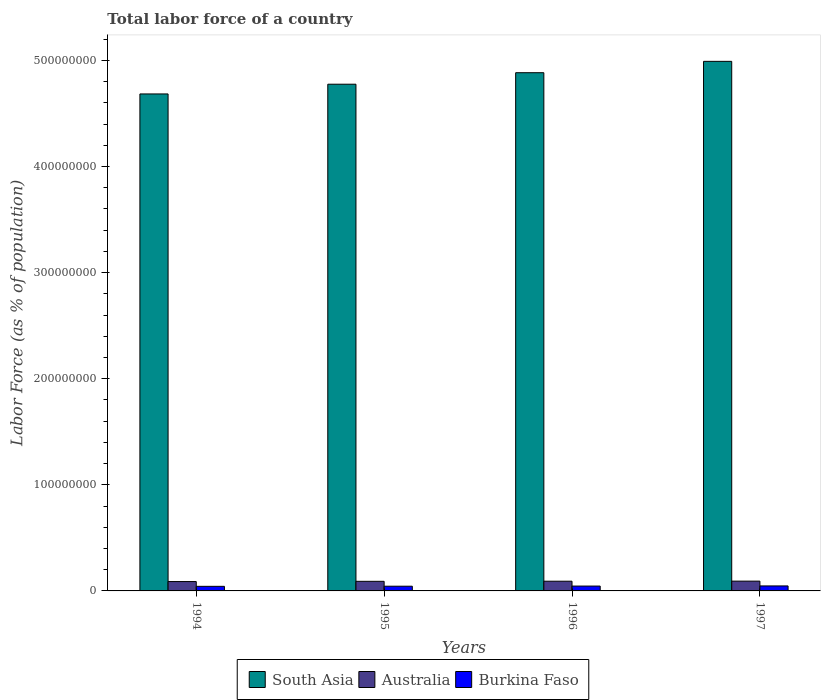How many groups of bars are there?
Give a very brief answer. 4. How many bars are there on the 1st tick from the right?
Offer a terse response. 3. In how many cases, is the number of bars for a given year not equal to the number of legend labels?
Provide a succinct answer. 0. What is the percentage of labor force in Australia in 1997?
Your answer should be very brief. 9.22e+06. Across all years, what is the maximum percentage of labor force in South Asia?
Offer a very short reply. 4.99e+08. Across all years, what is the minimum percentage of labor force in Australia?
Give a very brief answer. 8.83e+06. In which year was the percentage of labor force in Burkina Faso maximum?
Provide a succinct answer. 1997. What is the total percentage of labor force in Australia in the graph?
Make the answer very short. 3.63e+07. What is the difference between the percentage of labor force in Burkina Faso in 1995 and that in 1996?
Ensure brevity in your answer.  -1.23e+05. What is the difference between the percentage of labor force in Australia in 1997 and the percentage of labor force in South Asia in 1994?
Make the answer very short. -4.59e+08. What is the average percentage of labor force in South Asia per year?
Your answer should be compact. 4.83e+08. In the year 1996, what is the difference between the percentage of labor force in Burkina Faso and percentage of labor force in South Asia?
Offer a terse response. -4.84e+08. In how many years, is the percentage of labor force in Australia greater than 220000000 %?
Your answer should be very brief. 0. What is the ratio of the percentage of labor force in South Asia in 1994 to that in 1997?
Offer a terse response. 0.94. What is the difference between the highest and the second highest percentage of labor force in Burkina Faso?
Provide a succinct answer. 1.33e+05. What is the difference between the highest and the lowest percentage of labor force in Burkina Faso?
Offer a very short reply. 3.86e+05. What does the 3rd bar from the right in 1995 represents?
Keep it short and to the point. South Asia. How many bars are there?
Provide a succinct answer. 12. Are all the bars in the graph horizontal?
Give a very brief answer. No. How many years are there in the graph?
Provide a succinct answer. 4. What is the difference between two consecutive major ticks on the Y-axis?
Provide a succinct answer. 1.00e+08. Are the values on the major ticks of Y-axis written in scientific E-notation?
Provide a succinct answer. No. Does the graph contain grids?
Make the answer very short. No. What is the title of the graph?
Offer a terse response. Total labor force of a country. Does "St. Lucia" appear as one of the legend labels in the graph?
Your answer should be very brief. No. What is the label or title of the Y-axis?
Your answer should be compact. Labor Force (as % of population). What is the Labor Force (as % of population) of South Asia in 1994?
Provide a succinct answer. 4.68e+08. What is the Labor Force (as % of population) in Australia in 1994?
Keep it short and to the point. 8.83e+06. What is the Labor Force (as % of population) of Burkina Faso in 1994?
Offer a very short reply. 4.31e+06. What is the Labor Force (as % of population) of South Asia in 1995?
Ensure brevity in your answer.  4.78e+08. What is the Labor Force (as % of population) in Australia in 1995?
Your answer should be compact. 9.05e+06. What is the Labor Force (as % of population) of Burkina Faso in 1995?
Your answer should be compact. 4.45e+06. What is the Labor Force (as % of population) in South Asia in 1996?
Your answer should be very brief. 4.88e+08. What is the Labor Force (as % of population) in Australia in 1996?
Ensure brevity in your answer.  9.15e+06. What is the Labor Force (as % of population) of Burkina Faso in 1996?
Offer a terse response. 4.57e+06. What is the Labor Force (as % of population) in South Asia in 1997?
Keep it short and to the point. 4.99e+08. What is the Labor Force (as % of population) of Australia in 1997?
Provide a succinct answer. 9.22e+06. What is the Labor Force (as % of population) of Burkina Faso in 1997?
Your answer should be very brief. 4.70e+06. Across all years, what is the maximum Labor Force (as % of population) of South Asia?
Give a very brief answer. 4.99e+08. Across all years, what is the maximum Labor Force (as % of population) of Australia?
Ensure brevity in your answer.  9.22e+06. Across all years, what is the maximum Labor Force (as % of population) in Burkina Faso?
Keep it short and to the point. 4.70e+06. Across all years, what is the minimum Labor Force (as % of population) of South Asia?
Your answer should be compact. 4.68e+08. Across all years, what is the minimum Labor Force (as % of population) in Australia?
Provide a short and direct response. 8.83e+06. Across all years, what is the minimum Labor Force (as % of population) of Burkina Faso?
Your answer should be very brief. 4.31e+06. What is the total Labor Force (as % of population) of South Asia in the graph?
Give a very brief answer. 1.93e+09. What is the total Labor Force (as % of population) of Australia in the graph?
Offer a very short reply. 3.63e+07. What is the total Labor Force (as % of population) in Burkina Faso in the graph?
Your answer should be very brief. 1.80e+07. What is the difference between the Labor Force (as % of population) of South Asia in 1994 and that in 1995?
Your response must be concise. -9.17e+06. What is the difference between the Labor Force (as % of population) in Australia in 1994 and that in 1995?
Make the answer very short. -2.19e+05. What is the difference between the Labor Force (as % of population) in Burkina Faso in 1994 and that in 1995?
Make the answer very short. -1.31e+05. What is the difference between the Labor Force (as % of population) of South Asia in 1994 and that in 1996?
Offer a very short reply. -2.00e+07. What is the difference between the Labor Force (as % of population) in Australia in 1994 and that in 1996?
Your answer should be very brief. -3.21e+05. What is the difference between the Labor Force (as % of population) in Burkina Faso in 1994 and that in 1996?
Offer a very short reply. -2.54e+05. What is the difference between the Labor Force (as % of population) in South Asia in 1994 and that in 1997?
Make the answer very short. -3.07e+07. What is the difference between the Labor Force (as % of population) in Australia in 1994 and that in 1997?
Your answer should be very brief. -3.96e+05. What is the difference between the Labor Force (as % of population) in Burkina Faso in 1994 and that in 1997?
Give a very brief answer. -3.86e+05. What is the difference between the Labor Force (as % of population) of South Asia in 1995 and that in 1996?
Your answer should be compact. -1.08e+07. What is the difference between the Labor Force (as % of population) in Australia in 1995 and that in 1996?
Make the answer very short. -1.01e+05. What is the difference between the Labor Force (as % of population) of Burkina Faso in 1995 and that in 1996?
Provide a succinct answer. -1.23e+05. What is the difference between the Labor Force (as % of population) of South Asia in 1995 and that in 1997?
Provide a short and direct response. -2.15e+07. What is the difference between the Labor Force (as % of population) of Australia in 1995 and that in 1997?
Your response must be concise. -1.76e+05. What is the difference between the Labor Force (as % of population) of Burkina Faso in 1995 and that in 1997?
Provide a succinct answer. -2.56e+05. What is the difference between the Labor Force (as % of population) of South Asia in 1996 and that in 1997?
Your answer should be very brief. -1.07e+07. What is the difference between the Labor Force (as % of population) of Australia in 1996 and that in 1997?
Offer a very short reply. -7.51e+04. What is the difference between the Labor Force (as % of population) of Burkina Faso in 1996 and that in 1997?
Your answer should be compact. -1.33e+05. What is the difference between the Labor Force (as % of population) in South Asia in 1994 and the Labor Force (as % of population) in Australia in 1995?
Your response must be concise. 4.59e+08. What is the difference between the Labor Force (as % of population) in South Asia in 1994 and the Labor Force (as % of population) in Burkina Faso in 1995?
Give a very brief answer. 4.64e+08. What is the difference between the Labor Force (as % of population) in Australia in 1994 and the Labor Force (as % of population) in Burkina Faso in 1995?
Provide a succinct answer. 4.38e+06. What is the difference between the Labor Force (as % of population) of South Asia in 1994 and the Labor Force (as % of population) of Australia in 1996?
Give a very brief answer. 4.59e+08. What is the difference between the Labor Force (as % of population) in South Asia in 1994 and the Labor Force (as % of population) in Burkina Faso in 1996?
Provide a short and direct response. 4.64e+08. What is the difference between the Labor Force (as % of population) of Australia in 1994 and the Labor Force (as % of population) of Burkina Faso in 1996?
Keep it short and to the point. 4.26e+06. What is the difference between the Labor Force (as % of population) in South Asia in 1994 and the Labor Force (as % of population) in Australia in 1997?
Give a very brief answer. 4.59e+08. What is the difference between the Labor Force (as % of population) in South Asia in 1994 and the Labor Force (as % of population) in Burkina Faso in 1997?
Provide a succinct answer. 4.64e+08. What is the difference between the Labor Force (as % of population) of Australia in 1994 and the Labor Force (as % of population) of Burkina Faso in 1997?
Keep it short and to the point. 4.13e+06. What is the difference between the Labor Force (as % of population) in South Asia in 1995 and the Labor Force (as % of population) in Australia in 1996?
Your answer should be very brief. 4.68e+08. What is the difference between the Labor Force (as % of population) in South Asia in 1995 and the Labor Force (as % of population) in Burkina Faso in 1996?
Keep it short and to the point. 4.73e+08. What is the difference between the Labor Force (as % of population) of Australia in 1995 and the Labor Force (as % of population) of Burkina Faso in 1996?
Make the answer very short. 4.48e+06. What is the difference between the Labor Force (as % of population) in South Asia in 1995 and the Labor Force (as % of population) in Australia in 1997?
Offer a terse response. 4.68e+08. What is the difference between the Labor Force (as % of population) of South Asia in 1995 and the Labor Force (as % of population) of Burkina Faso in 1997?
Ensure brevity in your answer.  4.73e+08. What is the difference between the Labor Force (as % of population) in Australia in 1995 and the Labor Force (as % of population) in Burkina Faso in 1997?
Offer a very short reply. 4.35e+06. What is the difference between the Labor Force (as % of population) of South Asia in 1996 and the Labor Force (as % of population) of Australia in 1997?
Your answer should be very brief. 4.79e+08. What is the difference between the Labor Force (as % of population) of South Asia in 1996 and the Labor Force (as % of population) of Burkina Faso in 1997?
Your answer should be compact. 4.84e+08. What is the difference between the Labor Force (as % of population) of Australia in 1996 and the Labor Force (as % of population) of Burkina Faso in 1997?
Keep it short and to the point. 4.45e+06. What is the average Labor Force (as % of population) in South Asia per year?
Provide a succinct answer. 4.83e+08. What is the average Labor Force (as % of population) in Australia per year?
Offer a terse response. 9.06e+06. What is the average Labor Force (as % of population) of Burkina Faso per year?
Make the answer very short. 4.51e+06. In the year 1994, what is the difference between the Labor Force (as % of population) in South Asia and Labor Force (as % of population) in Australia?
Your response must be concise. 4.60e+08. In the year 1994, what is the difference between the Labor Force (as % of population) of South Asia and Labor Force (as % of population) of Burkina Faso?
Offer a very short reply. 4.64e+08. In the year 1994, what is the difference between the Labor Force (as % of population) of Australia and Labor Force (as % of population) of Burkina Faso?
Your answer should be very brief. 4.51e+06. In the year 1995, what is the difference between the Labor Force (as % of population) of South Asia and Labor Force (as % of population) of Australia?
Offer a very short reply. 4.68e+08. In the year 1995, what is the difference between the Labor Force (as % of population) in South Asia and Labor Force (as % of population) in Burkina Faso?
Provide a succinct answer. 4.73e+08. In the year 1995, what is the difference between the Labor Force (as % of population) of Australia and Labor Force (as % of population) of Burkina Faso?
Offer a terse response. 4.60e+06. In the year 1996, what is the difference between the Labor Force (as % of population) of South Asia and Labor Force (as % of population) of Australia?
Keep it short and to the point. 4.79e+08. In the year 1996, what is the difference between the Labor Force (as % of population) of South Asia and Labor Force (as % of population) of Burkina Faso?
Make the answer very short. 4.84e+08. In the year 1996, what is the difference between the Labor Force (as % of population) of Australia and Labor Force (as % of population) of Burkina Faso?
Your response must be concise. 4.58e+06. In the year 1997, what is the difference between the Labor Force (as % of population) in South Asia and Labor Force (as % of population) in Australia?
Your answer should be very brief. 4.90e+08. In the year 1997, what is the difference between the Labor Force (as % of population) of South Asia and Labor Force (as % of population) of Burkina Faso?
Provide a succinct answer. 4.94e+08. In the year 1997, what is the difference between the Labor Force (as % of population) in Australia and Labor Force (as % of population) in Burkina Faso?
Your answer should be compact. 4.52e+06. What is the ratio of the Labor Force (as % of population) in South Asia in 1994 to that in 1995?
Give a very brief answer. 0.98. What is the ratio of the Labor Force (as % of population) in Australia in 1994 to that in 1995?
Give a very brief answer. 0.98. What is the ratio of the Labor Force (as % of population) in Burkina Faso in 1994 to that in 1995?
Keep it short and to the point. 0.97. What is the ratio of the Labor Force (as % of population) of South Asia in 1994 to that in 1996?
Ensure brevity in your answer.  0.96. What is the ratio of the Labor Force (as % of population) in Burkina Faso in 1994 to that in 1996?
Provide a succinct answer. 0.94. What is the ratio of the Labor Force (as % of population) in South Asia in 1994 to that in 1997?
Your response must be concise. 0.94. What is the ratio of the Labor Force (as % of population) of Australia in 1994 to that in 1997?
Your response must be concise. 0.96. What is the ratio of the Labor Force (as % of population) in Burkina Faso in 1994 to that in 1997?
Provide a short and direct response. 0.92. What is the ratio of the Labor Force (as % of population) of South Asia in 1995 to that in 1996?
Your answer should be very brief. 0.98. What is the ratio of the Labor Force (as % of population) in Australia in 1995 to that in 1996?
Provide a succinct answer. 0.99. What is the ratio of the Labor Force (as % of population) of Burkina Faso in 1995 to that in 1996?
Your answer should be compact. 0.97. What is the ratio of the Labor Force (as % of population) in South Asia in 1995 to that in 1997?
Offer a terse response. 0.96. What is the ratio of the Labor Force (as % of population) of Australia in 1995 to that in 1997?
Your response must be concise. 0.98. What is the ratio of the Labor Force (as % of population) in Burkina Faso in 1995 to that in 1997?
Make the answer very short. 0.95. What is the ratio of the Labor Force (as % of population) of South Asia in 1996 to that in 1997?
Offer a very short reply. 0.98. What is the ratio of the Labor Force (as % of population) of Australia in 1996 to that in 1997?
Provide a succinct answer. 0.99. What is the ratio of the Labor Force (as % of population) of Burkina Faso in 1996 to that in 1997?
Offer a terse response. 0.97. What is the difference between the highest and the second highest Labor Force (as % of population) in South Asia?
Offer a terse response. 1.07e+07. What is the difference between the highest and the second highest Labor Force (as % of population) in Australia?
Make the answer very short. 7.51e+04. What is the difference between the highest and the second highest Labor Force (as % of population) of Burkina Faso?
Offer a terse response. 1.33e+05. What is the difference between the highest and the lowest Labor Force (as % of population) of South Asia?
Offer a terse response. 3.07e+07. What is the difference between the highest and the lowest Labor Force (as % of population) of Australia?
Offer a terse response. 3.96e+05. What is the difference between the highest and the lowest Labor Force (as % of population) in Burkina Faso?
Your answer should be very brief. 3.86e+05. 